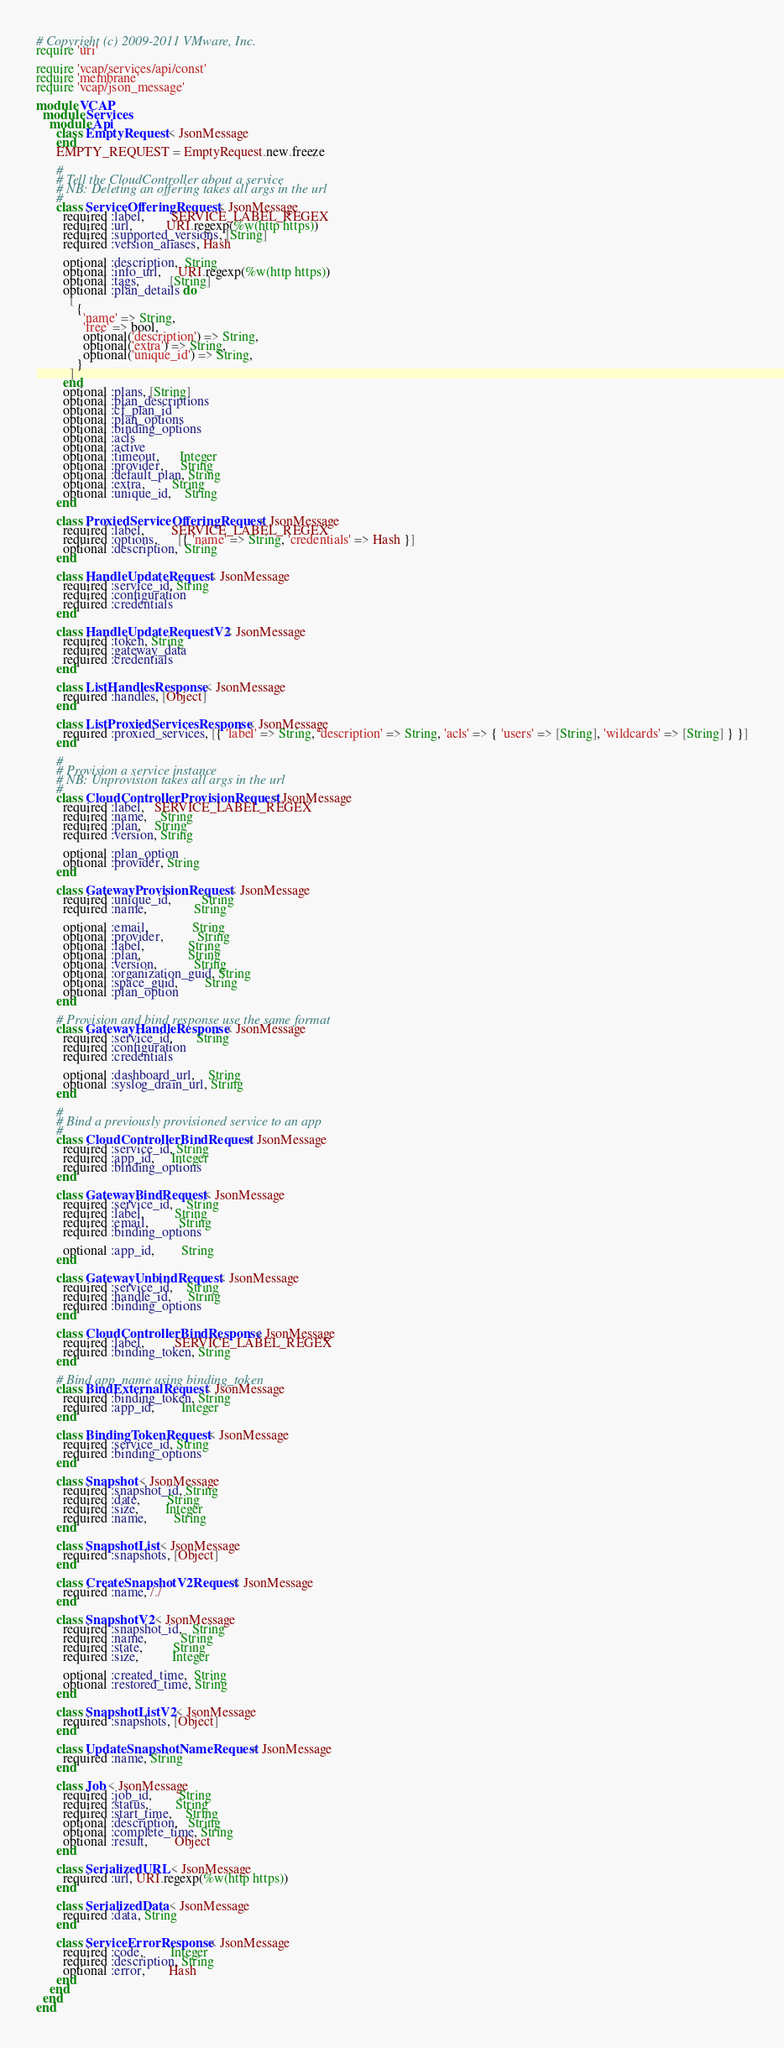Convert code to text. <code><loc_0><loc_0><loc_500><loc_500><_Ruby_># Copyright (c) 2009-2011 VMware, Inc.
require 'uri'

require 'vcap/services/api/const'
require 'membrane'
require 'vcap/json_message'

module VCAP
  module Services
    module Api
      class EmptyRequest < JsonMessage
      end
      EMPTY_REQUEST = EmptyRequest.new.freeze

      #
      # Tell the CloudController about a service
      # NB: Deleting an offering takes all args in the url
      #
      class ServiceOfferingRequest < JsonMessage
        required :label,        SERVICE_LABEL_REGEX
        required :url,          URI.regexp(%w(http https))
        required :supported_versions, [String]
        required :version_aliases, Hash

        optional :description,  String
        optional :info_url,     URI.regexp(%w(http https))
        optional :tags,         [String]
        optional :plan_details do
          [
            {
              'name' => String,
              'free' => bool,
              optional('description') => String,
              optional('extra') => String,
              optional('unique_id') => String,
            }
          ]
        end
        optional :plans, [String]
        optional :plan_descriptions
        optional :cf_plan_id
        optional :plan_options
        optional :binding_options
        optional :acls
        optional :active
        optional :timeout,      Integer
        optional :provider,     String
        optional :default_plan, String
        optional :extra,        String
        optional :unique_id,    String
      end

      class ProxiedServiceOfferingRequest < JsonMessage
        required :label,        SERVICE_LABEL_REGEX
        required :options,      [{ 'name' => String, 'credentials' => Hash }]
        optional :description,  String
      end

      class HandleUpdateRequest < JsonMessage
        required :service_id, String
        required :configuration
        required :credentials
      end

      class HandleUpdateRequestV2 < JsonMessage
        required :token, String
        required :gateway_data
        required :credentials
      end

      class ListHandlesResponse < JsonMessage
        required :handles, [Object]
      end

      class ListProxiedServicesResponse < JsonMessage
        required :proxied_services, [{ 'label' => String, 'description' => String, 'acls' => { 'users' => [String], 'wildcards' => [String] } }]
      end

      #
      # Provision a service instance
      # NB: Unprovision takes all args in the url
      #
      class CloudControllerProvisionRequest < JsonMessage
        required :label,   SERVICE_LABEL_REGEX
        required :name,    String
        required :plan,    String
        required :version, String

        optional :plan_option
        optional :provider, String
      end

      class GatewayProvisionRequest < JsonMessage
        required :unique_id,         String
        required :name,              String

        optional :email,             String
        optional :provider,          String
        optional :label,             String
        optional :plan,              String
        optional :version,           String
        optional :organization_guid, String
        optional :space_guid,        String
        optional :plan_option
      end

      # Provision and bind response use the same format
      class GatewayHandleResponse < JsonMessage
        required :service_id,       String
        required :configuration
        required :credentials

        optional :dashboard_url,    String
        optional :syslog_drain_url, String
      end

      #
      # Bind a previously provisioned service to an app
      #
      class CloudControllerBindRequest < JsonMessage
        required :service_id, String
        required :app_id,     Integer
        required :binding_options
      end

      class GatewayBindRequest < JsonMessage
        required :service_id,    String
        required :label,         String
        required :email,         String
        required :binding_options

        optional :app_id,        String
      end

      class GatewayUnbindRequest < JsonMessage
        required :service_id,    String
        required :handle_id,     String
        required :binding_options
      end

      class CloudControllerBindResponse < JsonMessage
        required :label,         SERVICE_LABEL_REGEX
        required :binding_token, String
      end

      # Bind app_name using binding_token
      class BindExternalRequest < JsonMessage
        required :binding_token, String
        required :app_id,        Integer
      end

      class BindingTokenRequest < JsonMessage
        required :service_id, String
        required :binding_options
      end

      class Snapshot < JsonMessage
        required :snapshot_id, String
        required :date,        String
        required :size,        Integer
        required :name,        String
      end

      class SnapshotList < JsonMessage
        required :snapshots, [Object]
      end

      class CreateSnapshotV2Request < JsonMessage
        required :name, /./
      end

      class SnapshotV2 < JsonMessage
        required :snapshot_id,   String
        required :name,          String
        required :state,         String
        required :size,          Integer

        optional :created_time,  String
        optional :restored_time, String
      end

      class SnapshotListV2 < JsonMessage
        required :snapshots, [Object]
      end

      class UpdateSnapshotNameRequest < JsonMessage
        required :name, String
      end

      class Job < JsonMessage
        required :job_id,        String
        required :status,        String
        required :start_time,    String
        optional :description,   String
        optional :complete_time, String
        optional :result,        Object
      end

      class SerializedURL < JsonMessage
        required :url, URI.regexp(%w(http https))
      end

      class SerializedData < JsonMessage
        required :data, String
      end

      class ServiceErrorResponse < JsonMessage
        required :code,        Integer
        required :description, String
        optional :error,       Hash
      end
    end
  end
end
</code> 